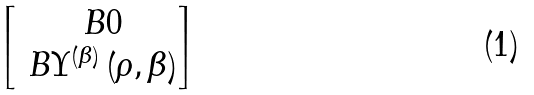<formula> <loc_0><loc_0><loc_500><loc_500>\begin{bmatrix} \ B { 0 } \\ \ B { \Upsilon } ^ { \left ( \beta \right ) } \left ( \rho , \beta \right ) \end{bmatrix}</formula> 